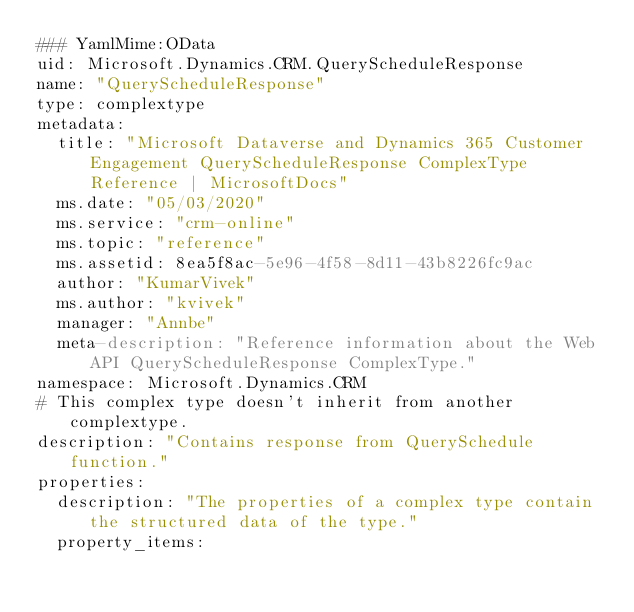Convert code to text. <code><loc_0><loc_0><loc_500><loc_500><_YAML_>### YamlMime:OData
uid: Microsoft.Dynamics.CRM.QueryScheduleResponse
name: "QueryScheduleResponse"
type: complextype
metadata: 
  title: "Microsoft Dataverse and Dynamics 365 Customer Engagement QueryScheduleResponse ComplexType Reference | MicrosoftDocs"
  ms.date: "05/03/2020"
  ms.service: "crm-online"
  ms.topic: "reference"
  ms.assetid: 8ea5f8ac-5e96-4f58-8d11-43b8226fc9ac
  author: "KumarVivek"
  ms.author: "kvivek"
  manager: "Annbe"
  meta-description: "Reference information about the Web API QueryScheduleResponse ComplexType."
namespace: Microsoft.Dynamics.CRM
# This complex type doesn't inherit from another complextype.
description: "Contains response from QuerySchedule function." 
properties:
  description: "The properties of a complex type contain the structured data of the type."
  property_items:</code> 